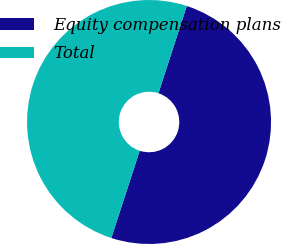Convert chart. <chart><loc_0><loc_0><loc_500><loc_500><pie_chart><fcel>Equity compensation plans<fcel>Total<nl><fcel>50.0%<fcel>50.0%<nl></chart> 